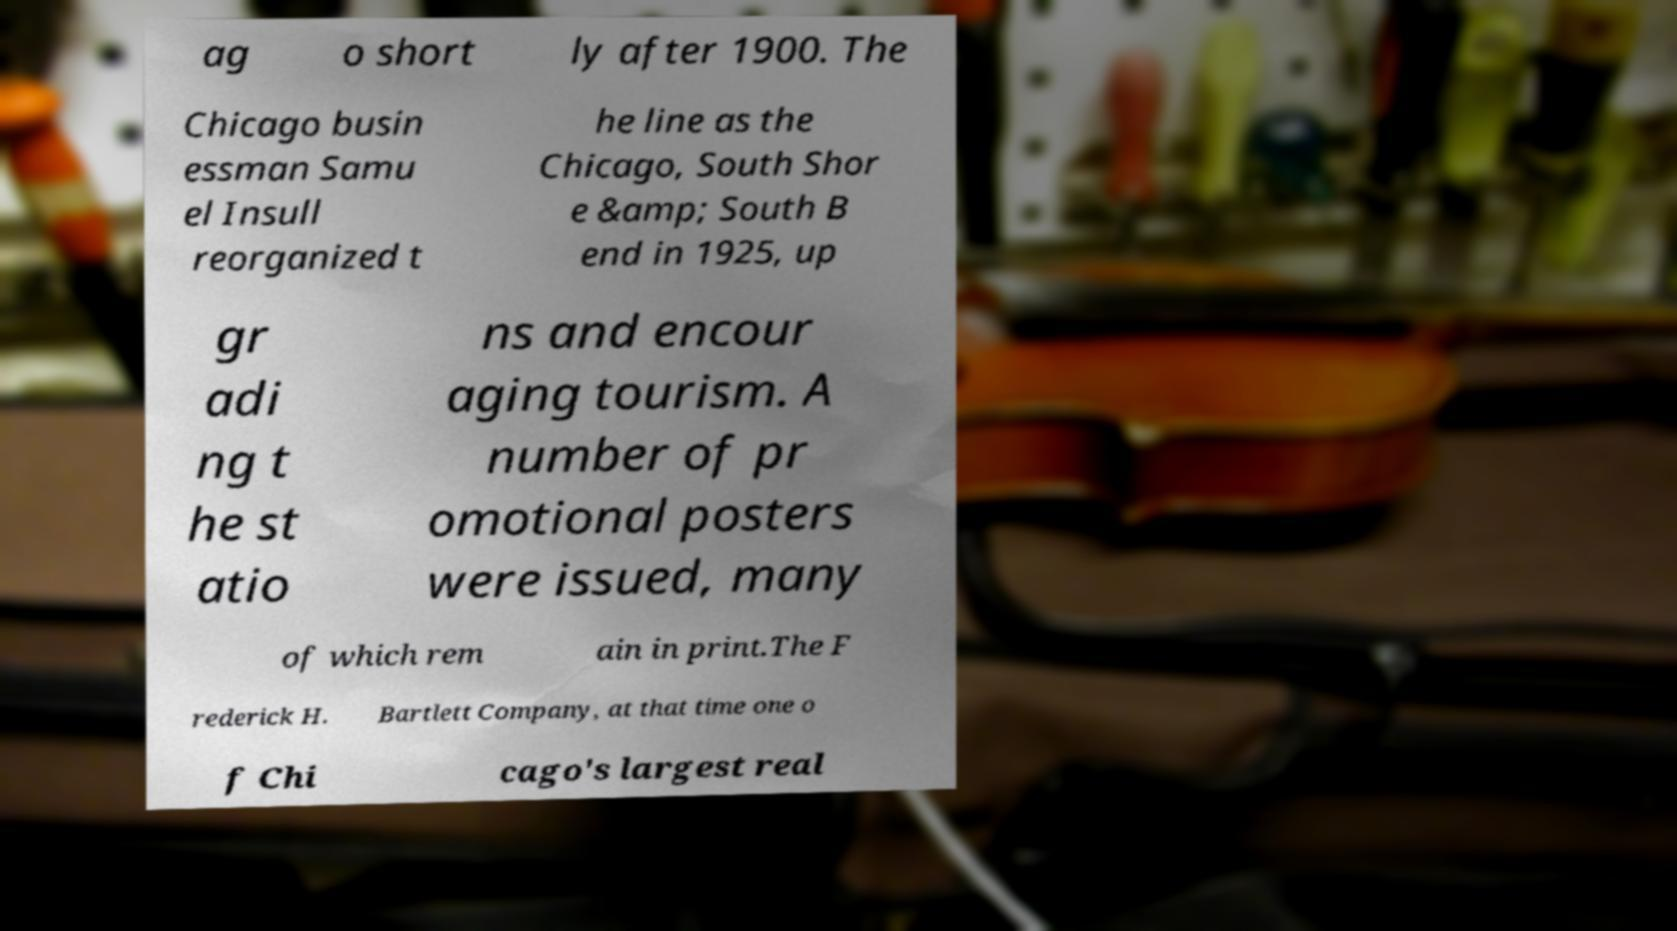What messages or text are displayed in this image? I need them in a readable, typed format. ag o short ly after 1900. The Chicago busin essman Samu el Insull reorganized t he line as the Chicago, South Shor e &amp; South B end in 1925, up gr adi ng t he st atio ns and encour aging tourism. A number of pr omotional posters were issued, many of which rem ain in print.The F rederick H. Bartlett Company, at that time one o f Chi cago's largest real 